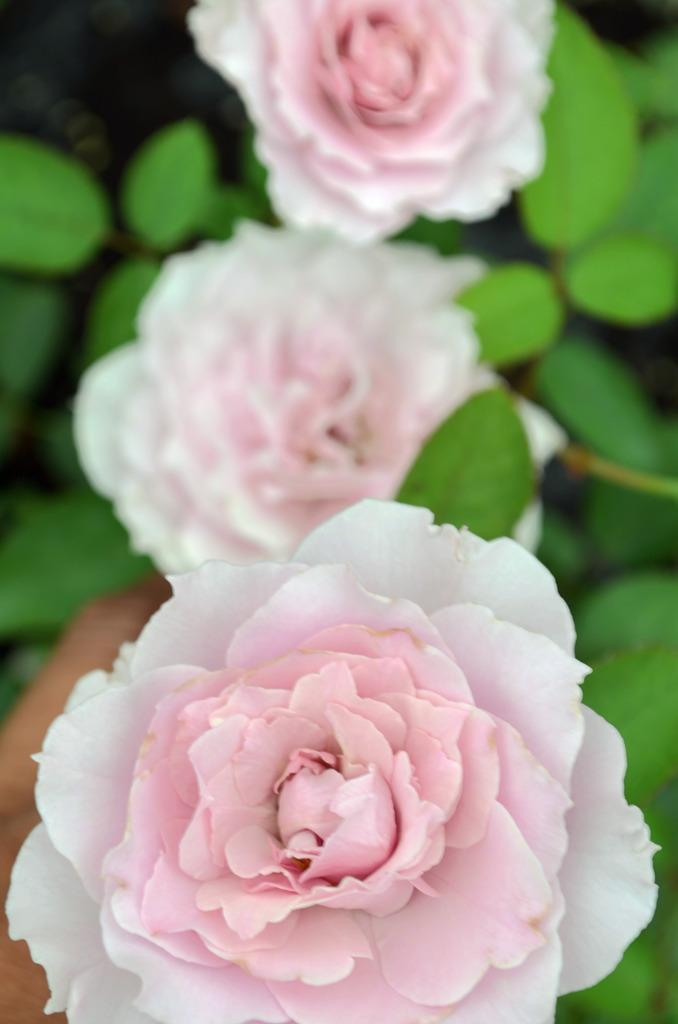What type of flora is present in the image? There are flowers in the image. What colors are the flowers? The flowers are pink and white in color. What are the flowers growing on? The flowers are on plants. What color are the plants? The plants are green in color. Can you describe the presence of a human element in the image? A human hand is visible in the image. What is the color of the background in the image? The background of the image is black in color. What type of ear is visible in the image? There is no ear present in the image; it features flowers on plants with a human hand and a black background. Can you describe the scene where the flowers are being pulled from the ground? There is no scene of flowers being pulled from the ground in the image; the flowers are shown on plants with a human hand and a black background. 